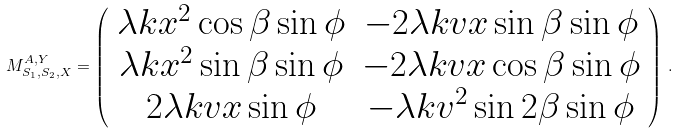<formula> <loc_0><loc_0><loc_500><loc_500>M ^ { A , Y } _ { S _ { 1 } , S _ { 2 } , X } = \left ( \begin{array} { c c } \lambda k x ^ { 2 } \cos \beta \sin \phi & - 2 \lambda k v x \sin \beta \sin \phi \\ \lambda k x ^ { 2 } \sin \beta \sin \phi & - 2 \lambda k v x \cos \beta \sin \phi \\ 2 \lambda k v x \sin \phi & - \lambda k v ^ { 2 } \sin 2 \beta \sin \phi \end{array} \right ) \, .</formula> 